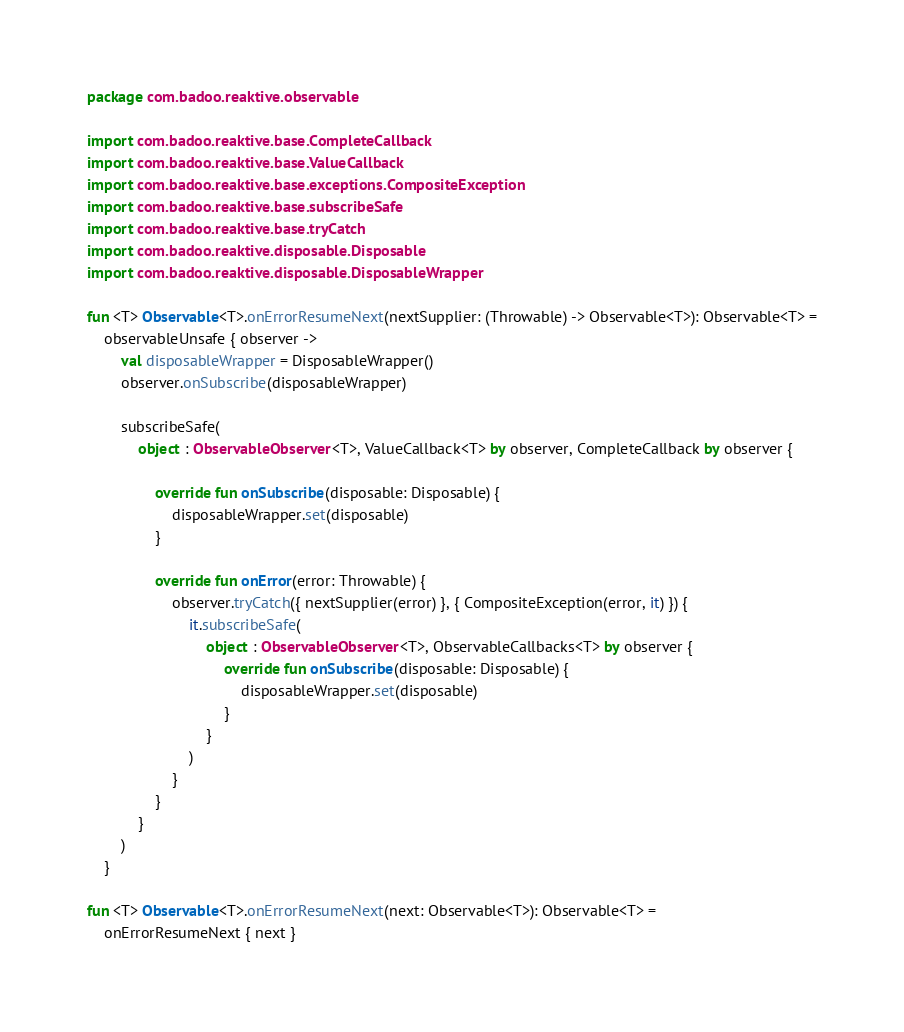Convert code to text. <code><loc_0><loc_0><loc_500><loc_500><_Kotlin_>package com.badoo.reaktive.observable

import com.badoo.reaktive.base.CompleteCallback
import com.badoo.reaktive.base.ValueCallback
import com.badoo.reaktive.base.exceptions.CompositeException
import com.badoo.reaktive.base.subscribeSafe
import com.badoo.reaktive.base.tryCatch
import com.badoo.reaktive.disposable.Disposable
import com.badoo.reaktive.disposable.DisposableWrapper

fun <T> Observable<T>.onErrorResumeNext(nextSupplier: (Throwable) -> Observable<T>): Observable<T> =
    observableUnsafe { observer ->
        val disposableWrapper = DisposableWrapper()
        observer.onSubscribe(disposableWrapper)

        subscribeSafe(
            object : ObservableObserver<T>, ValueCallback<T> by observer, CompleteCallback by observer {

                override fun onSubscribe(disposable: Disposable) {
                    disposableWrapper.set(disposable)
                }

                override fun onError(error: Throwable) {
                    observer.tryCatch({ nextSupplier(error) }, { CompositeException(error, it) }) {
                        it.subscribeSafe(
                            object : ObservableObserver<T>, ObservableCallbacks<T> by observer {
                                override fun onSubscribe(disposable: Disposable) {
                                    disposableWrapper.set(disposable)
                                }
                            }
                        )
                    }
                }
            }
        )
    }

fun <T> Observable<T>.onErrorResumeNext(next: Observable<T>): Observable<T> =
    onErrorResumeNext { next }</code> 